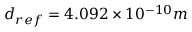<formula> <loc_0><loc_0><loc_500><loc_500>d _ { r e f } = 4 . 0 9 2 \times 1 0 ^ { - 1 0 } m</formula> 